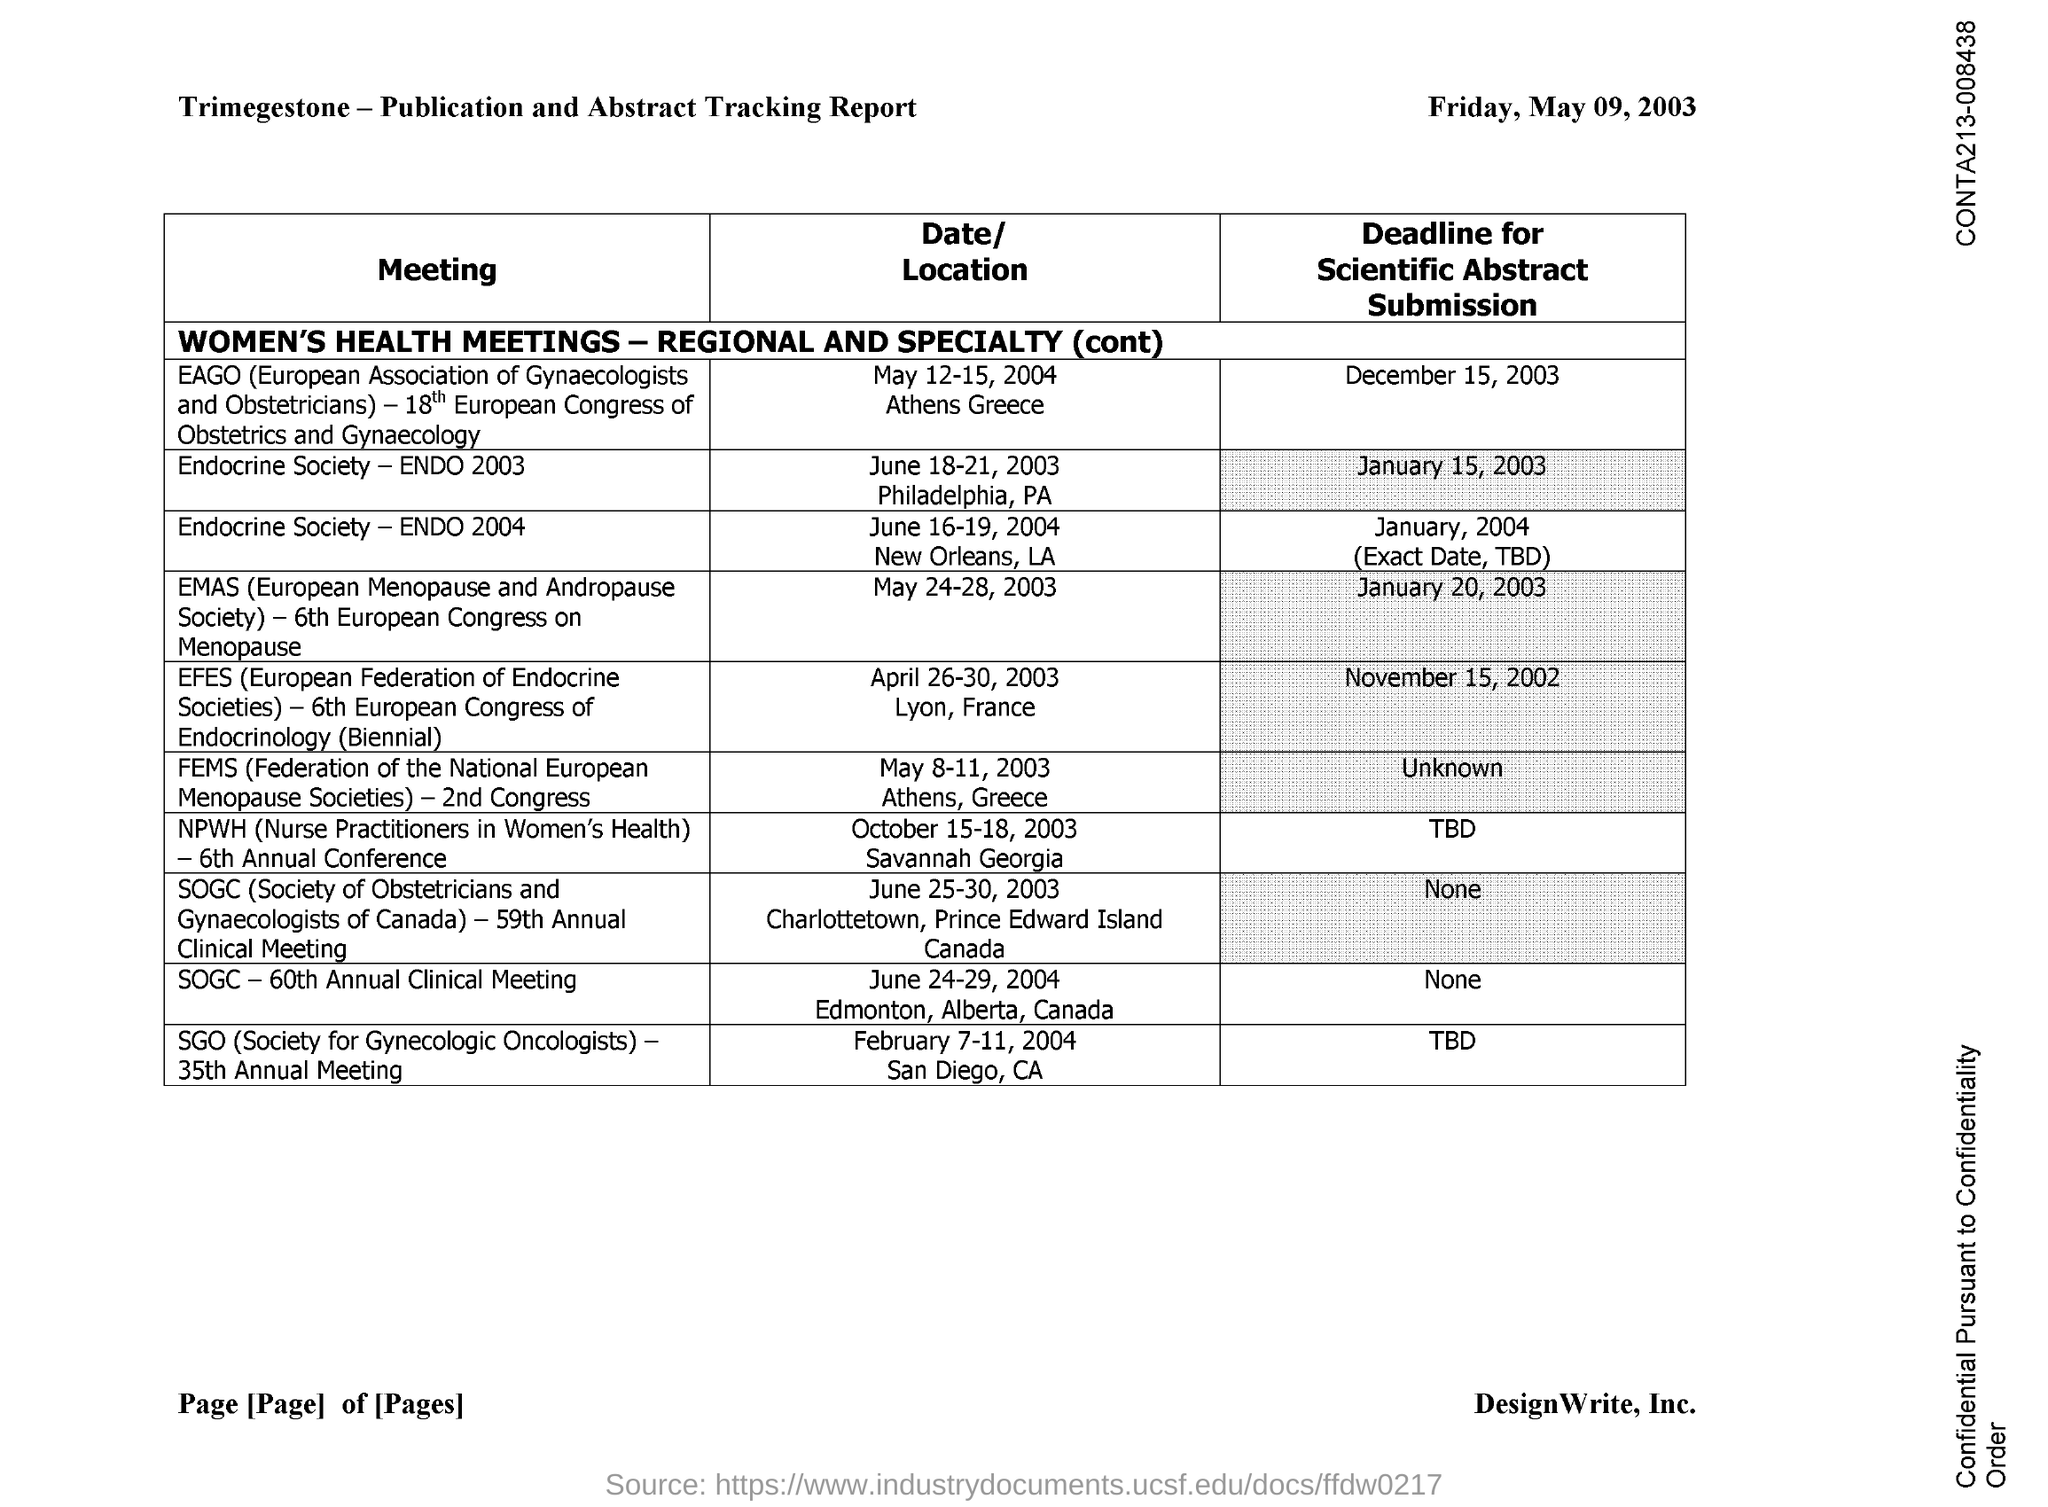Highlight a few significant elements in this photo. The Society of Obstetricians and Gynaecologists of Canada (SOGC) is a professional organization dedicated to the health of women and newborns in Canada. 